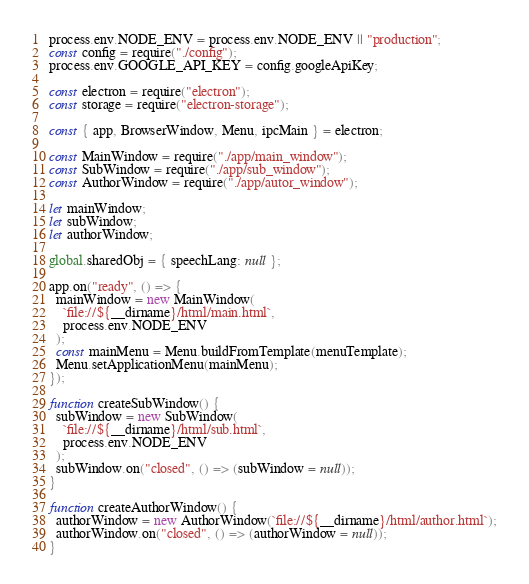Convert code to text. <code><loc_0><loc_0><loc_500><loc_500><_JavaScript_>process.env.NODE_ENV = process.env.NODE_ENV || "production";
const config = require("./config");
process.env.GOOGLE_API_KEY = config.googleApiKey;

const electron = require("electron");
const storage = require("electron-storage");

const { app, BrowserWindow, Menu, ipcMain } = electron;

const MainWindow = require("./app/main_window");
const SubWindow = require("./app/sub_window");
const AuthorWindow = require("./app/autor_window");

let mainWindow;
let subWindow;
let authorWindow;

global.sharedObj = { speechLang: null };

app.on("ready", () => {
  mainWindow = new MainWindow(
    `file://${__dirname}/html/main.html`,
    process.env.NODE_ENV
  );
  const mainMenu = Menu.buildFromTemplate(menuTemplate);
  Menu.setApplicationMenu(mainMenu);
});

function createSubWindow() {
  subWindow = new SubWindow(
    `file://${__dirname}/html/sub.html`,
    process.env.NODE_ENV
  );
  subWindow.on("closed", () => (subWindow = null));
}

function createAuthorWindow() {
  authorWindow = new AuthorWindow(`file://${__dirname}/html/author.html`);
  authorWindow.on("closed", () => (authorWindow = null));
}
</code> 